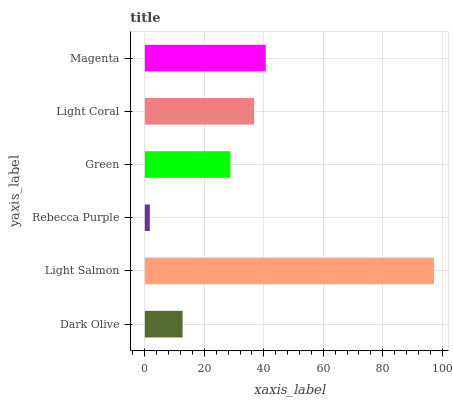Is Rebecca Purple the minimum?
Answer yes or no. Yes. Is Light Salmon the maximum?
Answer yes or no. Yes. Is Light Salmon the minimum?
Answer yes or no. No. Is Rebecca Purple the maximum?
Answer yes or no. No. Is Light Salmon greater than Rebecca Purple?
Answer yes or no. Yes. Is Rebecca Purple less than Light Salmon?
Answer yes or no. Yes. Is Rebecca Purple greater than Light Salmon?
Answer yes or no. No. Is Light Salmon less than Rebecca Purple?
Answer yes or no. No. Is Light Coral the high median?
Answer yes or no. Yes. Is Green the low median?
Answer yes or no. Yes. Is Dark Olive the high median?
Answer yes or no. No. Is Light Coral the low median?
Answer yes or no. No. 